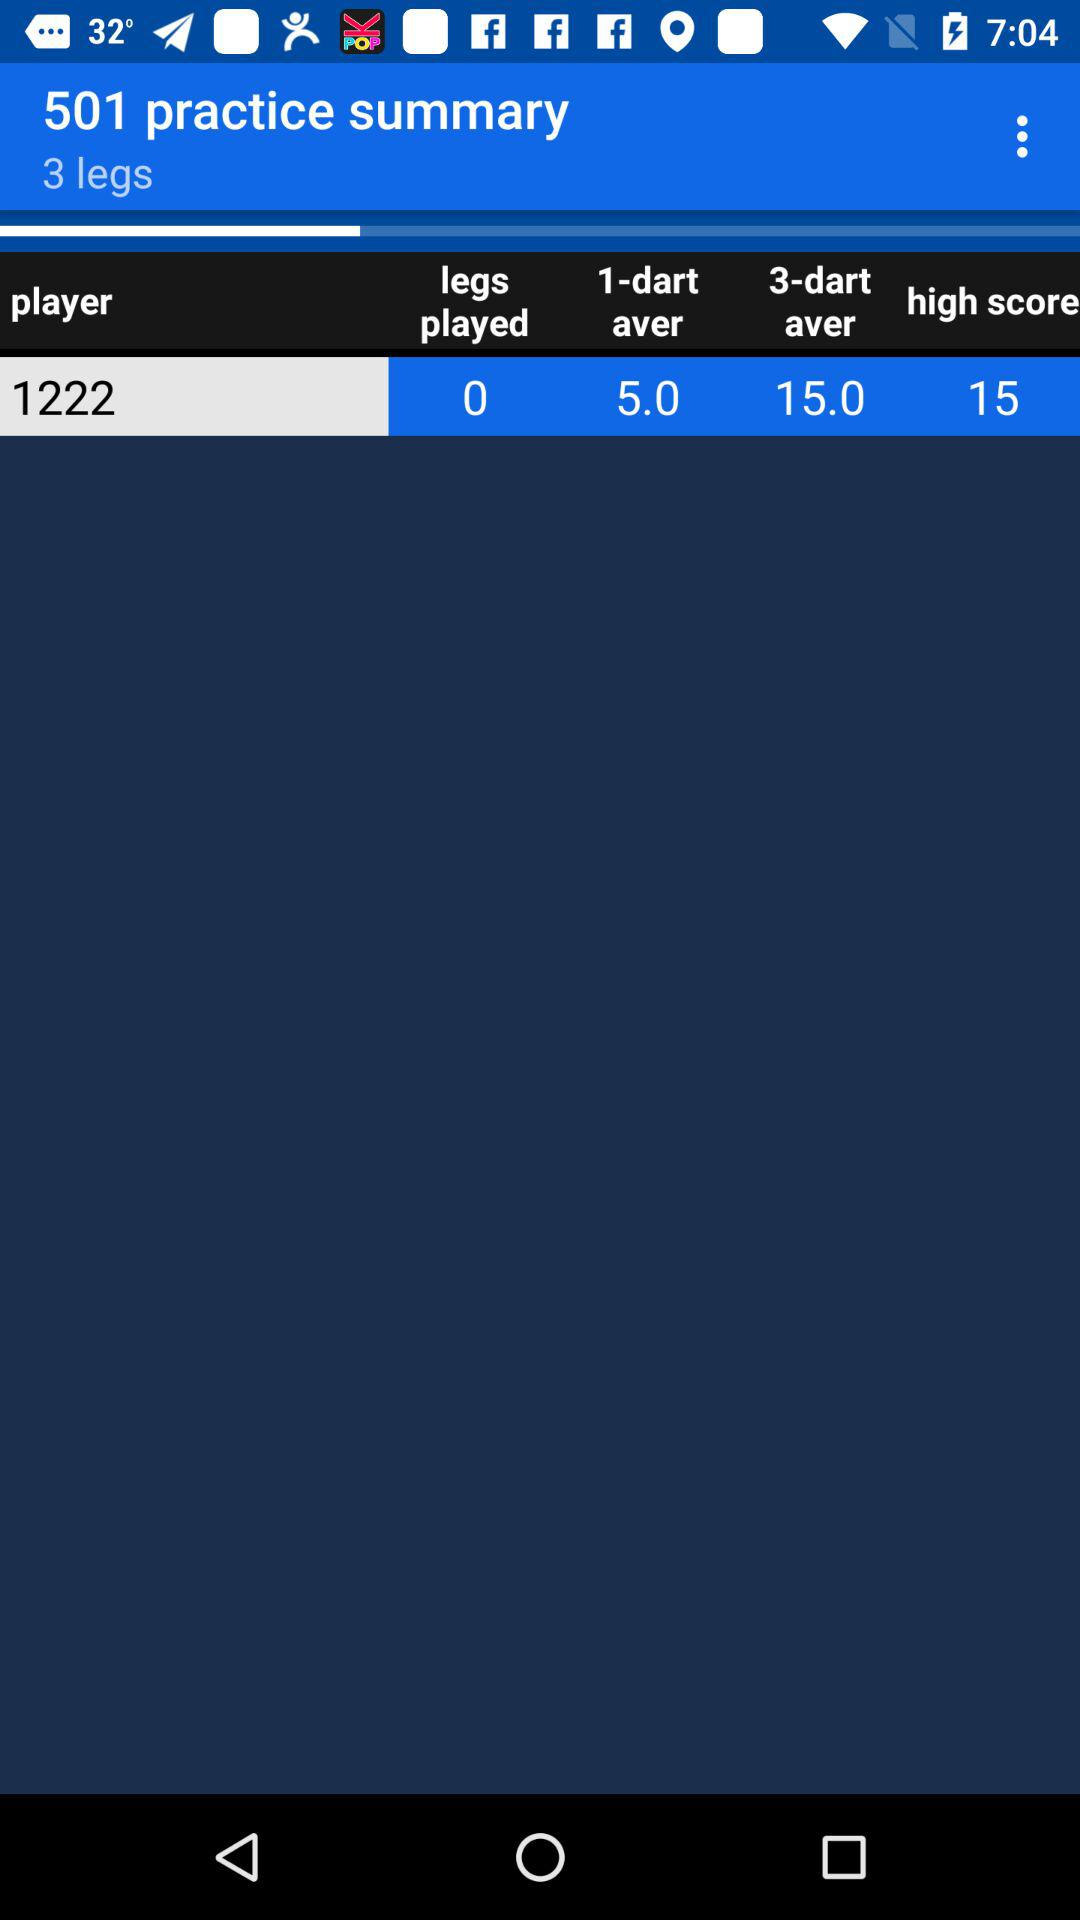What is the difference between the player's 3-dart average and their 1-dart average?
Answer the question using a single word or phrase. 10.0 